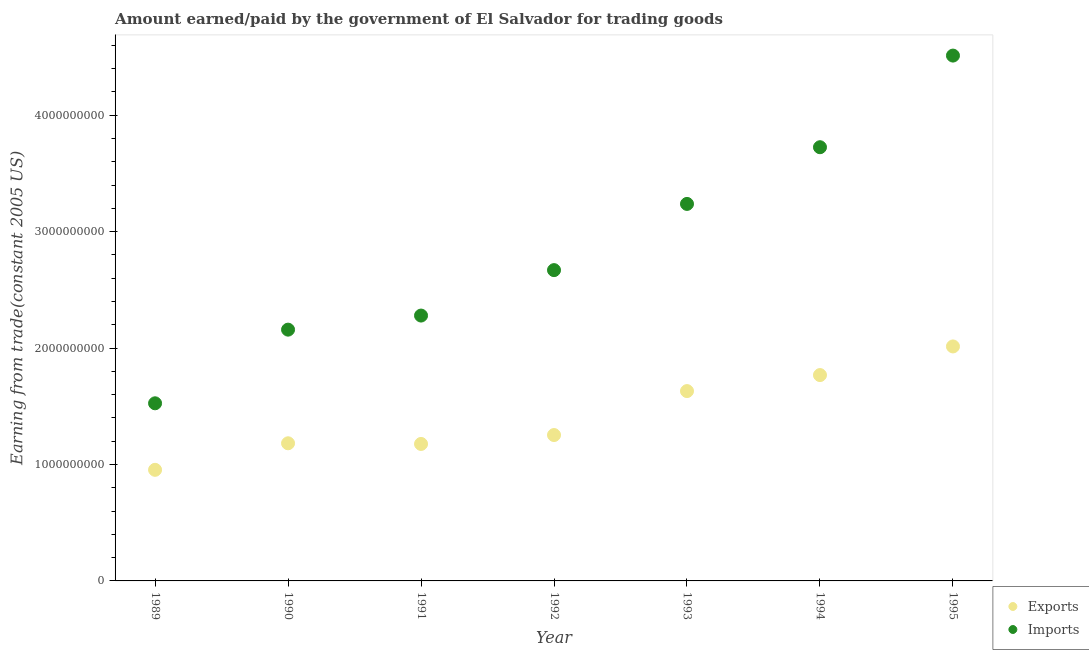How many different coloured dotlines are there?
Keep it short and to the point. 2. What is the amount paid for imports in 1991?
Your response must be concise. 2.28e+09. Across all years, what is the maximum amount earned from exports?
Keep it short and to the point. 2.01e+09. Across all years, what is the minimum amount paid for imports?
Provide a short and direct response. 1.53e+09. In which year was the amount paid for imports maximum?
Make the answer very short. 1995. In which year was the amount earned from exports minimum?
Provide a succinct answer. 1989. What is the total amount paid for imports in the graph?
Provide a short and direct response. 2.01e+1. What is the difference between the amount earned from exports in 1992 and that in 1993?
Provide a succinct answer. -3.77e+08. What is the difference between the amount earned from exports in 1993 and the amount paid for imports in 1991?
Provide a succinct answer. -6.49e+08. What is the average amount paid for imports per year?
Offer a terse response. 2.87e+09. In the year 1995, what is the difference between the amount earned from exports and amount paid for imports?
Keep it short and to the point. -2.50e+09. In how many years, is the amount paid for imports greater than 3200000000 US$?
Make the answer very short. 3. What is the ratio of the amount paid for imports in 1989 to that in 1994?
Give a very brief answer. 0.41. Is the difference between the amount paid for imports in 1991 and 1992 greater than the difference between the amount earned from exports in 1991 and 1992?
Your response must be concise. No. What is the difference between the highest and the second highest amount earned from exports?
Make the answer very short. 2.46e+08. What is the difference between the highest and the lowest amount paid for imports?
Offer a terse response. 2.99e+09. In how many years, is the amount paid for imports greater than the average amount paid for imports taken over all years?
Your response must be concise. 3. Is the amount paid for imports strictly less than the amount earned from exports over the years?
Give a very brief answer. No. How many dotlines are there?
Make the answer very short. 2. What is the difference between two consecutive major ticks on the Y-axis?
Offer a very short reply. 1.00e+09. Does the graph contain grids?
Your response must be concise. No. Where does the legend appear in the graph?
Your answer should be compact. Bottom right. How many legend labels are there?
Offer a terse response. 2. What is the title of the graph?
Keep it short and to the point. Amount earned/paid by the government of El Salvador for trading goods. Does "Private creditors" appear as one of the legend labels in the graph?
Give a very brief answer. No. What is the label or title of the X-axis?
Offer a terse response. Year. What is the label or title of the Y-axis?
Provide a succinct answer. Earning from trade(constant 2005 US). What is the Earning from trade(constant 2005 US) in Exports in 1989?
Provide a short and direct response. 9.54e+08. What is the Earning from trade(constant 2005 US) of Imports in 1989?
Give a very brief answer. 1.53e+09. What is the Earning from trade(constant 2005 US) in Exports in 1990?
Your answer should be very brief. 1.18e+09. What is the Earning from trade(constant 2005 US) of Imports in 1990?
Offer a very short reply. 2.16e+09. What is the Earning from trade(constant 2005 US) in Exports in 1991?
Make the answer very short. 1.18e+09. What is the Earning from trade(constant 2005 US) of Imports in 1991?
Your answer should be compact. 2.28e+09. What is the Earning from trade(constant 2005 US) in Exports in 1992?
Ensure brevity in your answer.  1.25e+09. What is the Earning from trade(constant 2005 US) in Imports in 1992?
Your response must be concise. 2.67e+09. What is the Earning from trade(constant 2005 US) of Exports in 1993?
Provide a short and direct response. 1.63e+09. What is the Earning from trade(constant 2005 US) in Imports in 1993?
Keep it short and to the point. 3.24e+09. What is the Earning from trade(constant 2005 US) of Exports in 1994?
Your answer should be compact. 1.77e+09. What is the Earning from trade(constant 2005 US) of Imports in 1994?
Give a very brief answer. 3.72e+09. What is the Earning from trade(constant 2005 US) in Exports in 1995?
Your response must be concise. 2.01e+09. What is the Earning from trade(constant 2005 US) of Imports in 1995?
Provide a succinct answer. 4.51e+09. Across all years, what is the maximum Earning from trade(constant 2005 US) in Exports?
Provide a short and direct response. 2.01e+09. Across all years, what is the maximum Earning from trade(constant 2005 US) in Imports?
Keep it short and to the point. 4.51e+09. Across all years, what is the minimum Earning from trade(constant 2005 US) in Exports?
Make the answer very short. 9.54e+08. Across all years, what is the minimum Earning from trade(constant 2005 US) of Imports?
Your response must be concise. 1.53e+09. What is the total Earning from trade(constant 2005 US) in Exports in the graph?
Keep it short and to the point. 9.98e+09. What is the total Earning from trade(constant 2005 US) of Imports in the graph?
Make the answer very short. 2.01e+1. What is the difference between the Earning from trade(constant 2005 US) in Exports in 1989 and that in 1990?
Make the answer very short. -2.28e+08. What is the difference between the Earning from trade(constant 2005 US) of Imports in 1989 and that in 1990?
Provide a short and direct response. -6.33e+08. What is the difference between the Earning from trade(constant 2005 US) in Exports in 1989 and that in 1991?
Your answer should be very brief. -2.22e+08. What is the difference between the Earning from trade(constant 2005 US) of Imports in 1989 and that in 1991?
Your response must be concise. -7.53e+08. What is the difference between the Earning from trade(constant 2005 US) of Exports in 1989 and that in 1992?
Keep it short and to the point. -2.99e+08. What is the difference between the Earning from trade(constant 2005 US) in Imports in 1989 and that in 1992?
Offer a terse response. -1.14e+09. What is the difference between the Earning from trade(constant 2005 US) of Exports in 1989 and that in 1993?
Your response must be concise. -6.76e+08. What is the difference between the Earning from trade(constant 2005 US) in Imports in 1989 and that in 1993?
Offer a very short reply. -1.71e+09. What is the difference between the Earning from trade(constant 2005 US) in Exports in 1989 and that in 1994?
Make the answer very short. -8.14e+08. What is the difference between the Earning from trade(constant 2005 US) of Imports in 1989 and that in 1994?
Offer a terse response. -2.20e+09. What is the difference between the Earning from trade(constant 2005 US) in Exports in 1989 and that in 1995?
Provide a succinct answer. -1.06e+09. What is the difference between the Earning from trade(constant 2005 US) of Imports in 1989 and that in 1995?
Keep it short and to the point. -2.99e+09. What is the difference between the Earning from trade(constant 2005 US) in Exports in 1990 and that in 1991?
Keep it short and to the point. 5.70e+06. What is the difference between the Earning from trade(constant 2005 US) of Imports in 1990 and that in 1991?
Offer a terse response. -1.21e+08. What is the difference between the Earning from trade(constant 2005 US) in Exports in 1990 and that in 1992?
Keep it short and to the point. -7.08e+07. What is the difference between the Earning from trade(constant 2005 US) of Imports in 1990 and that in 1992?
Your answer should be very brief. -5.11e+08. What is the difference between the Earning from trade(constant 2005 US) of Exports in 1990 and that in 1993?
Ensure brevity in your answer.  -4.48e+08. What is the difference between the Earning from trade(constant 2005 US) of Imports in 1990 and that in 1993?
Keep it short and to the point. -1.08e+09. What is the difference between the Earning from trade(constant 2005 US) of Exports in 1990 and that in 1994?
Offer a terse response. -5.86e+08. What is the difference between the Earning from trade(constant 2005 US) of Imports in 1990 and that in 1994?
Make the answer very short. -1.57e+09. What is the difference between the Earning from trade(constant 2005 US) of Exports in 1990 and that in 1995?
Provide a short and direct response. -8.32e+08. What is the difference between the Earning from trade(constant 2005 US) in Imports in 1990 and that in 1995?
Give a very brief answer. -2.35e+09. What is the difference between the Earning from trade(constant 2005 US) in Exports in 1991 and that in 1992?
Provide a succinct answer. -7.66e+07. What is the difference between the Earning from trade(constant 2005 US) in Imports in 1991 and that in 1992?
Make the answer very short. -3.90e+08. What is the difference between the Earning from trade(constant 2005 US) of Exports in 1991 and that in 1993?
Your answer should be very brief. -4.54e+08. What is the difference between the Earning from trade(constant 2005 US) of Imports in 1991 and that in 1993?
Your answer should be compact. -9.59e+08. What is the difference between the Earning from trade(constant 2005 US) in Exports in 1991 and that in 1994?
Your response must be concise. -5.92e+08. What is the difference between the Earning from trade(constant 2005 US) in Imports in 1991 and that in 1994?
Give a very brief answer. -1.45e+09. What is the difference between the Earning from trade(constant 2005 US) in Exports in 1991 and that in 1995?
Keep it short and to the point. -8.37e+08. What is the difference between the Earning from trade(constant 2005 US) of Imports in 1991 and that in 1995?
Give a very brief answer. -2.23e+09. What is the difference between the Earning from trade(constant 2005 US) of Exports in 1992 and that in 1993?
Give a very brief answer. -3.77e+08. What is the difference between the Earning from trade(constant 2005 US) in Imports in 1992 and that in 1993?
Keep it short and to the point. -5.69e+08. What is the difference between the Earning from trade(constant 2005 US) of Exports in 1992 and that in 1994?
Keep it short and to the point. -5.15e+08. What is the difference between the Earning from trade(constant 2005 US) in Imports in 1992 and that in 1994?
Your answer should be very brief. -1.06e+09. What is the difference between the Earning from trade(constant 2005 US) in Exports in 1992 and that in 1995?
Provide a succinct answer. -7.61e+08. What is the difference between the Earning from trade(constant 2005 US) of Imports in 1992 and that in 1995?
Ensure brevity in your answer.  -1.84e+09. What is the difference between the Earning from trade(constant 2005 US) of Exports in 1993 and that in 1994?
Your response must be concise. -1.38e+08. What is the difference between the Earning from trade(constant 2005 US) of Imports in 1993 and that in 1994?
Give a very brief answer. -4.87e+08. What is the difference between the Earning from trade(constant 2005 US) in Exports in 1993 and that in 1995?
Your response must be concise. -3.83e+08. What is the difference between the Earning from trade(constant 2005 US) in Imports in 1993 and that in 1995?
Provide a succinct answer. -1.27e+09. What is the difference between the Earning from trade(constant 2005 US) in Exports in 1994 and that in 1995?
Your answer should be very brief. -2.46e+08. What is the difference between the Earning from trade(constant 2005 US) in Imports in 1994 and that in 1995?
Provide a succinct answer. -7.87e+08. What is the difference between the Earning from trade(constant 2005 US) of Exports in 1989 and the Earning from trade(constant 2005 US) of Imports in 1990?
Keep it short and to the point. -1.20e+09. What is the difference between the Earning from trade(constant 2005 US) in Exports in 1989 and the Earning from trade(constant 2005 US) in Imports in 1991?
Offer a terse response. -1.32e+09. What is the difference between the Earning from trade(constant 2005 US) in Exports in 1989 and the Earning from trade(constant 2005 US) in Imports in 1992?
Provide a succinct answer. -1.72e+09. What is the difference between the Earning from trade(constant 2005 US) of Exports in 1989 and the Earning from trade(constant 2005 US) of Imports in 1993?
Provide a succinct answer. -2.28e+09. What is the difference between the Earning from trade(constant 2005 US) in Exports in 1989 and the Earning from trade(constant 2005 US) in Imports in 1994?
Give a very brief answer. -2.77e+09. What is the difference between the Earning from trade(constant 2005 US) in Exports in 1989 and the Earning from trade(constant 2005 US) in Imports in 1995?
Ensure brevity in your answer.  -3.56e+09. What is the difference between the Earning from trade(constant 2005 US) in Exports in 1990 and the Earning from trade(constant 2005 US) in Imports in 1991?
Your answer should be very brief. -1.10e+09. What is the difference between the Earning from trade(constant 2005 US) in Exports in 1990 and the Earning from trade(constant 2005 US) in Imports in 1992?
Offer a terse response. -1.49e+09. What is the difference between the Earning from trade(constant 2005 US) in Exports in 1990 and the Earning from trade(constant 2005 US) in Imports in 1993?
Your answer should be compact. -2.06e+09. What is the difference between the Earning from trade(constant 2005 US) of Exports in 1990 and the Earning from trade(constant 2005 US) of Imports in 1994?
Make the answer very short. -2.54e+09. What is the difference between the Earning from trade(constant 2005 US) of Exports in 1990 and the Earning from trade(constant 2005 US) of Imports in 1995?
Give a very brief answer. -3.33e+09. What is the difference between the Earning from trade(constant 2005 US) of Exports in 1991 and the Earning from trade(constant 2005 US) of Imports in 1992?
Give a very brief answer. -1.49e+09. What is the difference between the Earning from trade(constant 2005 US) of Exports in 1991 and the Earning from trade(constant 2005 US) of Imports in 1993?
Make the answer very short. -2.06e+09. What is the difference between the Earning from trade(constant 2005 US) of Exports in 1991 and the Earning from trade(constant 2005 US) of Imports in 1994?
Offer a very short reply. -2.55e+09. What is the difference between the Earning from trade(constant 2005 US) in Exports in 1991 and the Earning from trade(constant 2005 US) in Imports in 1995?
Offer a very short reply. -3.34e+09. What is the difference between the Earning from trade(constant 2005 US) in Exports in 1992 and the Earning from trade(constant 2005 US) in Imports in 1993?
Offer a terse response. -1.98e+09. What is the difference between the Earning from trade(constant 2005 US) in Exports in 1992 and the Earning from trade(constant 2005 US) in Imports in 1994?
Offer a very short reply. -2.47e+09. What is the difference between the Earning from trade(constant 2005 US) in Exports in 1992 and the Earning from trade(constant 2005 US) in Imports in 1995?
Provide a succinct answer. -3.26e+09. What is the difference between the Earning from trade(constant 2005 US) of Exports in 1993 and the Earning from trade(constant 2005 US) of Imports in 1994?
Your answer should be very brief. -2.09e+09. What is the difference between the Earning from trade(constant 2005 US) of Exports in 1993 and the Earning from trade(constant 2005 US) of Imports in 1995?
Give a very brief answer. -2.88e+09. What is the difference between the Earning from trade(constant 2005 US) of Exports in 1994 and the Earning from trade(constant 2005 US) of Imports in 1995?
Make the answer very short. -2.74e+09. What is the average Earning from trade(constant 2005 US) of Exports per year?
Give a very brief answer. 1.43e+09. What is the average Earning from trade(constant 2005 US) in Imports per year?
Give a very brief answer. 2.87e+09. In the year 1989, what is the difference between the Earning from trade(constant 2005 US) in Exports and Earning from trade(constant 2005 US) in Imports?
Offer a terse response. -5.71e+08. In the year 1990, what is the difference between the Earning from trade(constant 2005 US) in Exports and Earning from trade(constant 2005 US) in Imports?
Give a very brief answer. -9.76e+08. In the year 1991, what is the difference between the Earning from trade(constant 2005 US) in Exports and Earning from trade(constant 2005 US) in Imports?
Provide a short and direct response. -1.10e+09. In the year 1992, what is the difference between the Earning from trade(constant 2005 US) of Exports and Earning from trade(constant 2005 US) of Imports?
Provide a short and direct response. -1.42e+09. In the year 1993, what is the difference between the Earning from trade(constant 2005 US) in Exports and Earning from trade(constant 2005 US) in Imports?
Keep it short and to the point. -1.61e+09. In the year 1994, what is the difference between the Earning from trade(constant 2005 US) in Exports and Earning from trade(constant 2005 US) in Imports?
Make the answer very short. -1.96e+09. In the year 1995, what is the difference between the Earning from trade(constant 2005 US) in Exports and Earning from trade(constant 2005 US) in Imports?
Ensure brevity in your answer.  -2.50e+09. What is the ratio of the Earning from trade(constant 2005 US) in Exports in 1989 to that in 1990?
Your response must be concise. 0.81. What is the ratio of the Earning from trade(constant 2005 US) in Imports in 1989 to that in 1990?
Offer a terse response. 0.71. What is the ratio of the Earning from trade(constant 2005 US) of Exports in 1989 to that in 1991?
Keep it short and to the point. 0.81. What is the ratio of the Earning from trade(constant 2005 US) in Imports in 1989 to that in 1991?
Your answer should be compact. 0.67. What is the ratio of the Earning from trade(constant 2005 US) in Exports in 1989 to that in 1992?
Provide a succinct answer. 0.76. What is the ratio of the Earning from trade(constant 2005 US) of Imports in 1989 to that in 1992?
Make the answer very short. 0.57. What is the ratio of the Earning from trade(constant 2005 US) of Exports in 1989 to that in 1993?
Provide a succinct answer. 0.59. What is the ratio of the Earning from trade(constant 2005 US) of Imports in 1989 to that in 1993?
Provide a succinct answer. 0.47. What is the ratio of the Earning from trade(constant 2005 US) of Exports in 1989 to that in 1994?
Offer a very short reply. 0.54. What is the ratio of the Earning from trade(constant 2005 US) of Imports in 1989 to that in 1994?
Offer a terse response. 0.41. What is the ratio of the Earning from trade(constant 2005 US) of Exports in 1989 to that in 1995?
Provide a succinct answer. 0.47. What is the ratio of the Earning from trade(constant 2005 US) of Imports in 1989 to that in 1995?
Offer a terse response. 0.34. What is the ratio of the Earning from trade(constant 2005 US) in Imports in 1990 to that in 1991?
Your answer should be compact. 0.95. What is the ratio of the Earning from trade(constant 2005 US) of Exports in 1990 to that in 1992?
Ensure brevity in your answer.  0.94. What is the ratio of the Earning from trade(constant 2005 US) of Imports in 1990 to that in 1992?
Offer a terse response. 0.81. What is the ratio of the Earning from trade(constant 2005 US) in Exports in 1990 to that in 1993?
Offer a terse response. 0.72. What is the ratio of the Earning from trade(constant 2005 US) in Imports in 1990 to that in 1993?
Keep it short and to the point. 0.67. What is the ratio of the Earning from trade(constant 2005 US) of Exports in 1990 to that in 1994?
Your answer should be compact. 0.67. What is the ratio of the Earning from trade(constant 2005 US) of Imports in 1990 to that in 1994?
Your answer should be very brief. 0.58. What is the ratio of the Earning from trade(constant 2005 US) in Exports in 1990 to that in 1995?
Your response must be concise. 0.59. What is the ratio of the Earning from trade(constant 2005 US) in Imports in 1990 to that in 1995?
Make the answer very short. 0.48. What is the ratio of the Earning from trade(constant 2005 US) of Exports in 1991 to that in 1992?
Your answer should be compact. 0.94. What is the ratio of the Earning from trade(constant 2005 US) of Imports in 1991 to that in 1992?
Your answer should be compact. 0.85. What is the ratio of the Earning from trade(constant 2005 US) in Exports in 1991 to that in 1993?
Provide a succinct answer. 0.72. What is the ratio of the Earning from trade(constant 2005 US) of Imports in 1991 to that in 1993?
Your response must be concise. 0.7. What is the ratio of the Earning from trade(constant 2005 US) in Exports in 1991 to that in 1994?
Provide a short and direct response. 0.67. What is the ratio of the Earning from trade(constant 2005 US) of Imports in 1991 to that in 1994?
Your answer should be very brief. 0.61. What is the ratio of the Earning from trade(constant 2005 US) in Exports in 1991 to that in 1995?
Your answer should be very brief. 0.58. What is the ratio of the Earning from trade(constant 2005 US) in Imports in 1991 to that in 1995?
Ensure brevity in your answer.  0.51. What is the ratio of the Earning from trade(constant 2005 US) of Exports in 1992 to that in 1993?
Your answer should be very brief. 0.77. What is the ratio of the Earning from trade(constant 2005 US) of Imports in 1992 to that in 1993?
Offer a terse response. 0.82. What is the ratio of the Earning from trade(constant 2005 US) of Exports in 1992 to that in 1994?
Make the answer very short. 0.71. What is the ratio of the Earning from trade(constant 2005 US) of Imports in 1992 to that in 1994?
Provide a short and direct response. 0.72. What is the ratio of the Earning from trade(constant 2005 US) of Exports in 1992 to that in 1995?
Keep it short and to the point. 0.62. What is the ratio of the Earning from trade(constant 2005 US) in Imports in 1992 to that in 1995?
Your response must be concise. 0.59. What is the ratio of the Earning from trade(constant 2005 US) in Exports in 1993 to that in 1994?
Your response must be concise. 0.92. What is the ratio of the Earning from trade(constant 2005 US) of Imports in 1993 to that in 1994?
Your response must be concise. 0.87. What is the ratio of the Earning from trade(constant 2005 US) of Exports in 1993 to that in 1995?
Your response must be concise. 0.81. What is the ratio of the Earning from trade(constant 2005 US) of Imports in 1993 to that in 1995?
Provide a short and direct response. 0.72. What is the ratio of the Earning from trade(constant 2005 US) of Exports in 1994 to that in 1995?
Give a very brief answer. 0.88. What is the ratio of the Earning from trade(constant 2005 US) in Imports in 1994 to that in 1995?
Provide a succinct answer. 0.83. What is the difference between the highest and the second highest Earning from trade(constant 2005 US) of Exports?
Provide a succinct answer. 2.46e+08. What is the difference between the highest and the second highest Earning from trade(constant 2005 US) of Imports?
Provide a short and direct response. 7.87e+08. What is the difference between the highest and the lowest Earning from trade(constant 2005 US) of Exports?
Provide a short and direct response. 1.06e+09. What is the difference between the highest and the lowest Earning from trade(constant 2005 US) of Imports?
Provide a succinct answer. 2.99e+09. 